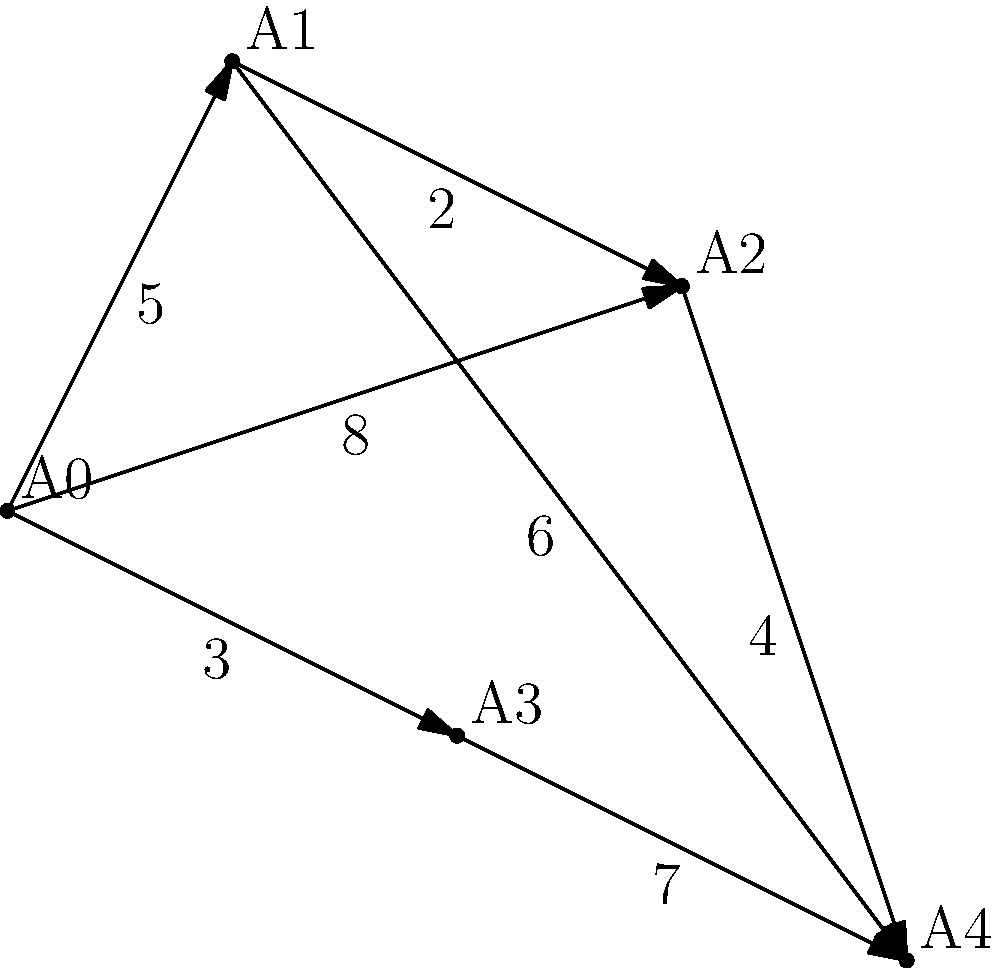In Tongzhou District, a new waste management system is being implemented. The weighted graph represents different collection points (A0 to A4) and the distances between them. If a garbage truck starts at point A0 and needs to visit all points before returning to A0, what is the minimum total distance it must travel? Assume the truck can revisit points if necessary. To find the minimum total distance, we need to solve the Traveling Salesman Problem (TSP) for this weighted graph. Here's a step-by-step approach:

1. Identify all possible routes:
   - A0 → A1 → A2 → A3 → A4 → A0
   - A0 → A1 → A2 → A4 → A3 → A0
   - A0 → A1 → A4 → A2 → A3 → A0
   - A0 → A2 → A1 → A4 → A3 → A0
   - A0 → A2 → A4 → A1 → A3 → A0
   - A0 → A3 → A1 → A2 → A4 → A0
   - A0 → A3 → A1 → A4 → A2 → A0
   - A0 → A3 → A4 → A1 → A2 → A0

2. Calculate the distance for each route:
   - A0 → A1 → A2 → A3 → A4 → A0: 5 + 2 + 11 + 7 + 8 = 33
   - A0 → A1 → A2 → A4 → A3 → A0: 5 + 2 + 4 + 7 + 3 = 21
   - A0 → A1 → A4 → A2 → A3 → A0: 5 + 6 + 4 + 11 + 3 = 29
   - A0 → A2 → A1 → A4 → A3 → A0: 8 + 2 + 6 + 7 + 3 = 26
   - A0 → A2 → A4 → A1 → A3 → A0: 8 + 4 + 6 + 5 + 3 = 26
   - A0 → A3 → A1 → A2 → A4 → A0: 3 + 8 + 2 + 4 + 8 = 25
   - A0 → A3 → A1 → A4 → A2 → A0: 3 + 8 + 6 + 4 + 8 = 29
   - A0 → A3 → A4 → A1 → A2 → A0: 3 + 7 + 6 + 2 + 8 = 26

3. Identify the minimum distance:
   The route with the minimum distance is A0 → A1 → A2 → A4 → A3 → A0, with a total distance of 21.

Therefore, the minimum total distance the garbage truck must travel is 21 units.
Answer: 21 units 